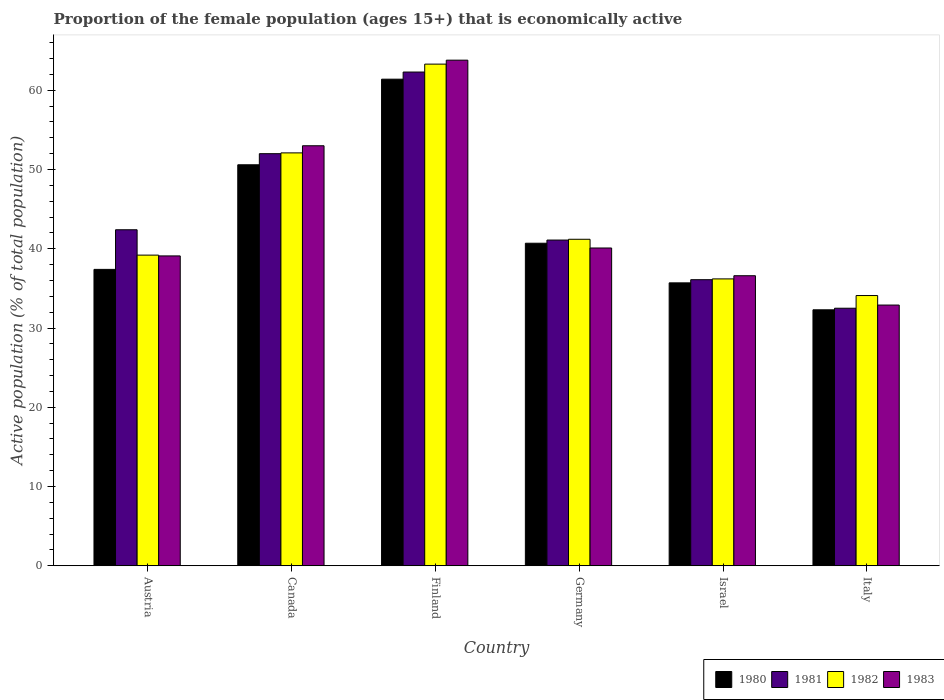How many different coloured bars are there?
Give a very brief answer. 4. How many bars are there on the 5th tick from the right?
Your answer should be very brief. 4. What is the label of the 1st group of bars from the left?
Your answer should be very brief. Austria. In how many cases, is the number of bars for a given country not equal to the number of legend labels?
Your answer should be compact. 0. What is the proportion of the female population that is economically active in 1983 in Austria?
Keep it short and to the point. 39.1. Across all countries, what is the maximum proportion of the female population that is economically active in 1980?
Ensure brevity in your answer.  61.4. Across all countries, what is the minimum proportion of the female population that is economically active in 1981?
Offer a very short reply. 32.5. In which country was the proportion of the female population that is economically active in 1983 maximum?
Provide a short and direct response. Finland. In which country was the proportion of the female population that is economically active in 1980 minimum?
Give a very brief answer. Italy. What is the total proportion of the female population that is economically active in 1983 in the graph?
Make the answer very short. 265.5. What is the difference between the proportion of the female population that is economically active in 1980 in Canada and that in Germany?
Your response must be concise. 9.9. What is the difference between the proportion of the female population that is economically active in 1980 in Israel and the proportion of the female population that is economically active in 1982 in Austria?
Your answer should be very brief. -3.5. What is the average proportion of the female population that is economically active in 1983 per country?
Ensure brevity in your answer.  44.25. What is the difference between the proportion of the female population that is economically active of/in 1981 and proportion of the female population that is economically active of/in 1983 in Austria?
Ensure brevity in your answer.  3.3. In how many countries, is the proportion of the female population that is economically active in 1982 greater than 2 %?
Your answer should be compact. 6. What is the ratio of the proportion of the female population that is economically active in 1980 in Austria to that in Israel?
Give a very brief answer. 1.05. Is the proportion of the female population that is economically active in 1981 in Canada less than that in Germany?
Keep it short and to the point. No. Is the difference between the proportion of the female population that is economically active in 1981 in Austria and Israel greater than the difference between the proportion of the female population that is economically active in 1983 in Austria and Israel?
Keep it short and to the point. Yes. What is the difference between the highest and the second highest proportion of the female population that is economically active in 1983?
Provide a short and direct response. -12.9. What is the difference between the highest and the lowest proportion of the female population that is economically active in 1983?
Offer a terse response. 30.9. Is the sum of the proportion of the female population that is economically active in 1981 in Germany and Italy greater than the maximum proportion of the female population that is economically active in 1983 across all countries?
Keep it short and to the point. Yes. Is it the case that in every country, the sum of the proportion of the female population that is economically active in 1983 and proportion of the female population that is economically active in 1981 is greater than the sum of proportion of the female population that is economically active in 1982 and proportion of the female population that is economically active in 1980?
Give a very brief answer. No. What does the 4th bar from the left in Israel represents?
Your answer should be compact. 1983. Is it the case that in every country, the sum of the proportion of the female population that is economically active in 1981 and proportion of the female population that is economically active in 1983 is greater than the proportion of the female population that is economically active in 1982?
Your answer should be compact. Yes. How many bars are there?
Your answer should be compact. 24. Does the graph contain grids?
Your response must be concise. No. Where does the legend appear in the graph?
Offer a very short reply. Bottom right. What is the title of the graph?
Make the answer very short. Proportion of the female population (ages 15+) that is economically active. What is the label or title of the X-axis?
Make the answer very short. Country. What is the label or title of the Y-axis?
Give a very brief answer. Active population (% of total population). What is the Active population (% of total population) of 1980 in Austria?
Give a very brief answer. 37.4. What is the Active population (% of total population) of 1981 in Austria?
Provide a succinct answer. 42.4. What is the Active population (% of total population) of 1982 in Austria?
Make the answer very short. 39.2. What is the Active population (% of total population) in 1983 in Austria?
Ensure brevity in your answer.  39.1. What is the Active population (% of total population) of 1980 in Canada?
Provide a short and direct response. 50.6. What is the Active population (% of total population) of 1981 in Canada?
Offer a very short reply. 52. What is the Active population (% of total population) of 1982 in Canada?
Offer a terse response. 52.1. What is the Active population (% of total population) of 1983 in Canada?
Your answer should be compact. 53. What is the Active population (% of total population) of 1980 in Finland?
Keep it short and to the point. 61.4. What is the Active population (% of total population) in 1981 in Finland?
Make the answer very short. 62.3. What is the Active population (% of total population) of 1982 in Finland?
Provide a short and direct response. 63.3. What is the Active population (% of total population) of 1983 in Finland?
Make the answer very short. 63.8. What is the Active population (% of total population) in 1980 in Germany?
Ensure brevity in your answer.  40.7. What is the Active population (% of total population) in 1981 in Germany?
Your answer should be very brief. 41.1. What is the Active population (% of total population) in 1982 in Germany?
Provide a succinct answer. 41.2. What is the Active population (% of total population) in 1983 in Germany?
Provide a short and direct response. 40.1. What is the Active population (% of total population) in 1980 in Israel?
Make the answer very short. 35.7. What is the Active population (% of total population) in 1981 in Israel?
Make the answer very short. 36.1. What is the Active population (% of total population) in 1982 in Israel?
Make the answer very short. 36.2. What is the Active population (% of total population) of 1983 in Israel?
Offer a very short reply. 36.6. What is the Active population (% of total population) of 1980 in Italy?
Provide a succinct answer. 32.3. What is the Active population (% of total population) of 1981 in Italy?
Offer a terse response. 32.5. What is the Active population (% of total population) of 1982 in Italy?
Keep it short and to the point. 34.1. What is the Active population (% of total population) of 1983 in Italy?
Make the answer very short. 32.9. Across all countries, what is the maximum Active population (% of total population) in 1980?
Provide a short and direct response. 61.4. Across all countries, what is the maximum Active population (% of total population) of 1981?
Offer a very short reply. 62.3. Across all countries, what is the maximum Active population (% of total population) in 1982?
Provide a succinct answer. 63.3. Across all countries, what is the maximum Active population (% of total population) of 1983?
Your answer should be compact. 63.8. Across all countries, what is the minimum Active population (% of total population) of 1980?
Keep it short and to the point. 32.3. Across all countries, what is the minimum Active population (% of total population) of 1981?
Your response must be concise. 32.5. Across all countries, what is the minimum Active population (% of total population) in 1982?
Give a very brief answer. 34.1. Across all countries, what is the minimum Active population (% of total population) in 1983?
Your answer should be very brief. 32.9. What is the total Active population (% of total population) of 1980 in the graph?
Provide a short and direct response. 258.1. What is the total Active population (% of total population) in 1981 in the graph?
Your answer should be compact. 266.4. What is the total Active population (% of total population) of 1982 in the graph?
Your answer should be compact. 266.1. What is the total Active population (% of total population) in 1983 in the graph?
Offer a terse response. 265.5. What is the difference between the Active population (% of total population) in 1980 in Austria and that in Canada?
Your answer should be very brief. -13.2. What is the difference between the Active population (% of total population) of 1981 in Austria and that in Canada?
Keep it short and to the point. -9.6. What is the difference between the Active population (% of total population) in 1982 in Austria and that in Canada?
Give a very brief answer. -12.9. What is the difference between the Active population (% of total population) of 1983 in Austria and that in Canada?
Keep it short and to the point. -13.9. What is the difference between the Active population (% of total population) of 1981 in Austria and that in Finland?
Make the answer very short. -19.9. What is the difference between the Active population (% of total population) of 1982 in Austria and that in Finland?
Give a very brief answer. -24.1. What is the difference between the Active population (% of total population) of 1983 in Austria and that in Finland?
Provide a short and direct response. -24.7. What is the difference between the Active population (% of total population) in 1982 in Austria and that in Germany?
Your response must be concise. -2. What is the difference between the Active population (% of total population) in 1980 in Austria and that in Israel?
Give a very brief answer. 1.7. What is the difference between the Active population (% of total population) of 1982 in Austria and that in Israel?
Your response must be concise. 3. What is the difference between the Active population (% of total population) in 1983 in Austria and that in Israel?
Provide a short and direct response. 2.5. What is the difference between the Active population (% of total population) of 1980 in Austria and that in Italy?
Offer a very short reply. 5.1. What is the difference between the Active population (% of total population) in 1981 in Austria and that in Italy?
Provide a short and direct response. 9.9. What is the difference between the Active population (% of total population) in 1981 in Canada and that in Germany?
Give a very brief answer. 10.9. What is the difference between the Active population (% of total population) of 1982 in Canada and that in Germany?
Your answer should be very brief. 10.9. What is the difference between the Active population (% of total population) in 1980 in Canada and that in Israel?
Ensure brevity in your answer.  14.9. What is the difference between the Active population (% of total population) in 1983 in Canada and that in Italy?
Offer a very short reply. 20.1. What is the difference between the Active population (% of total population) of 1980 in Finland and that in Germany?
Your answer should be compact. 20.7. What is the difference between the Active population (% of total population) of 1981 in Finland and that in Germany?
Offer a terse response. 21.2. What is the difference between the Active population (% of total population) of 1982 in Finland and that in Germany?
Keep it short and to the point. 22.1. What is the difference between the Active population (% of total population) in 1983 in Finland and that in Germany?
Your answer should be compact. 23.7. What is the difference between the Active population (% of total population) in 1980 in Finland and that in Israel?
Your answer should be very brief. 25.7. What is the difference between the Active population (% of total population) in 1981 in Finland and that in Israel?
Offer a very short reply. 26.2. What is the difference between the Active population (% of total population) in 1982 in Finland and that in Israel?
Your answer should be very brief. 27.1. What is the difference between the Active population (% of total population) of 1983 in Finland and that in Israel?
Provide a succinct answer. 27.2. What is the difference between the Active population (% of total population) of 1980 in Finland and that in Italy?
Offer a very short reply. 29.1. What is the difference between the Active population (% of total population) in 1981 in Finland and that in Italy?
Make the answer very short. 29.8. What is the difference between the Active population (% of total population) of 1982 in Finland and that in Italy?
Your answer should be very brief. 29.2. What is the difference between the Active population (% of total population) of 1983 in Finland and that in Italy?
Keep it short and to the point. 30.9. What is the difference between the Active population (% of total population) of 1982 in Germany and that in Israel?
Provide a short and direct response. 5. What is the difference between the Active population (% of total population) of 1983 in Germany and that in Israel?
Your answer should be compact. 3.5. What is the difference between the Active population (% of total population) of 1981 in Germany and that in Italy?
Ensure brevity in your answer.  8.6. What is the difference between the Active population (% of total population) in 1982 in Germany and that in Italy?
Offer a terse response. 7.1. What is the difference between the Active population (% of total population) in 1980 in Israel and that in Italy?
Your answer should be compact. 3.4. What is the difference between the Active population (% of total population) in 1980 in Austria and the Active population (% of total population) in 1981 in Canada?
Make the answer very short. -14.6. What is the difference between the Active population (% of total population) in 1980 in Austria and the Active population (% of total population) in 1982 in Canada?
Provide a short and direct response. -14.7. What is the difference between the Active population (% of total population) in 1980 in Austria and the Active population (% of total population) in 1983 in Canada?
Your answer should be compact. -15.6. What is the difference between the Active population (% of total population) in 1981 in Austria and the Active population (% of total population) in 1982 in Canada?
Your answer should be compact. -9.7. What is the difference between the Active population (% of total population) of 1981 in Austria and the Active population (% of total population) of 1983 in Canada?
Give a very brief answer. -10.6. What is the difference between the Active population (% of total population) in 1980 in Austria and the Active population (% of total population) in 1981 in Finland?
Make the answer very short. -24.9. What is the difference between the Active population (% of total population) of 1980 in Austria and the Active population (% of total population) of 1982 in Finland?
Offer a very short reply. -25.9. What is the difference between the Active population (% of total population) in 1980 in Austria and the Active population (% of total population) in 1983 in Finland?
Provide a succinct answer. -26.4. What is the difference between the Active population (% of total population) in 1981 in Austria and the Active population (% of total population) in 1982 in Finland?
Provide a short and direct response. -20.9. What is the difference between the Active population (% of total population) in 1981 in Austria and the Active population (% of total population) in 1983 in Finland?
Give a very brief answer. -21.4. What is the difference between the Active population (% of total population) of 1982 in Austria and the Active population (% of total population) of 1983 in Finland?
Give a very brief answer. -24.6. What is the difference between the Active population (% of total population) in 1980 in Austria and the Active population (% of total population) in 1981 in Germany?
Ensure brevity in your answer.  -3.7. What is the difference between the Active population (% of total population) in 1980 in Austria and the Active population (% of total population) in 1983 in Germany?
Provide a short and direct response. -2.7. What is the difference between the Active population (% of total population) of 1981 in Austria and the Active population (% of total population) of 1982 in Germany?
Keep it short and to the point. 1.2. What is the difference between the Active population (% of total population) in 1981 in Austria and the Active population (% of total population) in 1983 in Israel?
Offer a very short reply. 5.8. What is the difference between the Active population (% of total population) in 1982 in Austria and the Active population (% of total population) in 1983 in Israel?
Offer a very short reply. 2.6. What is the difference between the Active population (% of total population) of 1982 in Austria and the Active population (% of total population) of 1983 in Italy?
Your response must be concise. 6.3. What is the difference between the Active population (% of total population) of 1980 in Canada and the Active population (% of total population) of 1981 in Finland?
Your answer should be compact. -11.7. What is the difference between the Active population (% of total population) in 1981 in Canada and the Active population (% of total population) in 1983 in Finland?
Offer a very short reply. -11.8. What is the difference between the Active population (% of total population) of 1980 in Canada and the Active population (% of total population) of 1981 in Germany?
Provide a short and direct response. 9.5. What is the difference between the Active population (% of total population) of 1981 in Canada and the Active population (% of total population) of 1982 in Germany?
Ensure brevity in your answer.  10.8. What is the difference between the Active population (% of total population) in 1981 in Canada and the Active population (% of total population) in 1983 in Germany?
Your answer should be compact. 11.9. What is the difference between the Active population (% of total population) in 1982 in Canada and the Active population (% of total population) in 1983 in Germany?
Offer a terse response. 12. What is the difference between the Active population (% of total population) of 1980 in Canada and the Active population (% of total population) of 1982 in Israel?
Give a very brief answer. 14.4. What is the difference between the Active population (% of total population) of 1981 in Canada and the Active population (% of total population) of 1983 in Israel?
Offer a terse response. 15.4. What is the difference between the Active population (% of total population) in 1982 in Canada and the Active population (% of total population) in 1983 in Israel?
Keep it short and to the point. 15.5. What is the difference between the Active population (% of total population) of 1980 in Canada and the Active population (% of total population) of 1981 in Italy?
Provide a short and direct response. 18.1. What is the difference between the Active population (% of total population) of 1980 in Canada and the Active population (% of total population) of 1982 in Italy?
Provide a short and direct response. 16.5. What is the difference between the Active population (% of total population) of 1980 in Canada and the Active population (% of total population) of 1983 in Italy?
Offer a terse response. 17.7. What is the difference between the Active population (% of total population) of 1980 in Finland and the Active population (% of total population) of 1981 in Germany?
Ensure brevity in your answer.  20.3. What is the difference between the Active population (% of total population) of 1980 in Finland and the Active population (% of total population) of 1982 in Germany?
Keep it short and to the point. 20.2. What is the difference between the Active population (% of total population) in 1980 in Finland and the Active population (% of total population) in 1983 in Germany?
Offer a terse response. 21.3. What is the difference between the Active population (% of total population) of 1981 in Finland and the Active population (% of total population) of 1982 in Germany?
Give a very brief answer. 21.1. What is the difference between the Active population (% of total population) in 1981 in Finland and the Active population (% of total population) in 1983 in Germany?
Your response must be concise. 22.2. What is the difference between the Active population (% of total population) of 1982 in Finland and the Active population (% of total population) of 1983 in Germany?
Offer a terse response. 23.2. What is the difference between the Active population (% of total population) in 1980 in Finland and the Active population (% of total population) in 1981 in Israel?
Provide a short and direct response. 25.3. What is the difference between the Active population (% of total population) in 1980 in Finland and the Active population (% of total population) in 1982 in Israel?
Your answer should be compact. 25.2. What is the difference between the Active population (% of total population) in 1980 in Finland and the Active population (% of total population) in 1983 in Israel?
Provide a succinct answer. 24.8. What is the difference between the Active population (% of total population) in 1981 in Finland and the Active population (% of total population) in 1982 in Israel?
Your answer should be compact. 26.1. What is the difference between the Active population (% of total population) of 1981 in Finland and the Active population (% of total population) of 1983 in Israel?
Your answer should be compact. 25.7. What is the difference between the Active population (% of total population) of 1982 in Finland and the Active population (% of total population) of 1983 in Israel?
Provide a succinct answer. 26.7. What is the difference between the Active population (% of total population) of 1980 in Finland and the Active population (% of total population) of 1981 in Italy?
Offer a terse response. 28.9. What is the difference between the Active population (% of total population) in 1980 in Finland and the Active population (% of total population) in 1982 in Italy?
Make the answer very short. 27.3. What is the difference between the Active population (% of total population) of 1981 in Finland and the Active population (% of total population) of 1982 in Italy?
Your response must be concise. 28.2. What is the difference between the Active population (% of total population) in 1981 in Finland and the Active population (% of total population) in 1983 in Italy?
Your answer should be very brief. 29.4. What is the difference between the Active population (% of total population) in 1982 in Finland and the Active population (% of total population) in 1983 in Italy?
Your response must be concise. 30.4. What is the difference between the Active population (% of total population) in 1980 in Germany and the Active population (% of total population) in 1983 in Israel?
Give a very brief answer. 4.1. What is the difference between the Active population (% of total population) of 1981 in Germany and the Active population (% of total population) of 1982 in Israel?
Provide a short and direct response. 4.9. What is the difference between the Active population (% of total population) in 1980 in Germany and the Active population (% of total population) in 1982 in Italy?
Offer a very short reply. 6.6. What is the difference between the Active population (% of total population) of 1980 in Israel and the Active population (% of total population) of 1981 in Italy?
Your response must be concise. 3.2. What is the difference between the Active population (% of total population) of 1980 in Israel and the Active population (% of total population) of 1982 in Italy?
Make the answer very short. 1.6. What is the difference between the Active population (% of total population) of 1980 in Israel and the Active population (% of total population) of 1983 in Italy?
Ensure brevity in your answer.  2.8. What is the difference between the Active population (% of total population) in 1981 in Israel and the Active population (% of total population) in 1982 in Italy?
Make the answer very short. 2. What is the difference between the Active population (% of total population) in 1981 in Israel and the Active population (% of total population) in 1983 in Italy?
Give a very brief answer. 3.2. What is the average Active population (% of total population) in 1980 per country?
Give a very brief answer. 43.02. What is the average Active population (% of total population) in 1981 per country?
Provide a short and direct response. 44.4. What is the average Active population (% of total population) of 1982 per country?
Provide a succinct answer. 44.35. What is the average Active population (% of total population) of 1983 per country?
Your answer should be very brief. 44.25. What is the difference between the Active population (% of total population) of 1980 and Active population (% of total population) of 1981 in Austria?
Make the answer very short. -5. What is the difference between the Active population (% of total population) in 1980 and Active population (% of total population) in 1983 in Austria?
Provide a succinct answer. -1.7. What is the difference between the Active population (% of total population) in 1981 and Active population (% of total population) in 1982 in Austria?
Ensure brevity in your answer.  3.2. What is the difference between the Active population (% of total population) of 1981 and Active population (% of total population) of 1983 in Austria?
Your answer should be compact. 3.3. What is the difference between the Active population (% of total population) in 1982 and Active population (% of total population) in 1983 in Austria?
Keep it short and to the point. 0.1. What is the difference between the Active population (% of total population) of 1980 and Active population (% of total population) of 1981 in Canada?
Offer a very short reply. -1.4. What is the difference between the Active population (% of total population) in 1980 and Active population (% of total population) in 1983 in Canada?
Keep it short and to the point. -2.4. What is the difference between the Active population (% of total population) in 1981 and Active population (% of total population) in 1983 in Canada?
Provide a short and direct response. -1. What is the difference between the Active population (% of total population) in 1982 and Active population (% of total population) in 1983 in Canada?
Your answer should be compact. -0.9. What is the difference between the Active population (% of total population) in 1980 and Active population (% of total population) in 1981 in Finland?
Make the answer very short. -0.9. What is the difference between the Active population (% of total population) of 1980 and Active population (% of total population) of 1982 in Germany?
Ensure brevity in your answer.  -0.5. What is the difference between the Active population (% of total population) in 1981 and Active population (% of total population) in 1982 in Germany?
Provide a short and direct response. -0.1. What is the difference between the Active population (% of total population) in 1980 and Active population (% of total population) in 1981 in Israel?
Ensure brevity in your answer.  -0.4. What is the difference between the Active population (% of total population) in 1982 and Active population (% of total population) in 1983 in Israel?
Your answer should be very brief. -0.4. What is the difference between the Active population (% of total population) in 1980 and Active population (% of total population) in 1981 in Italy?
Make the answer very short. -0.2. What is the difference between the Active population (% of total population) of 1980 and Active population (% of total population) of 1982 in Italy?
Ensure brevity in your answer.  -1.8. What is the difference between the Active population (% of total population) in 1981 and Active population (% of total population) in 1983 in Italy?
Offer a terse response. -0.4. What is the difference between the Active population (% of total population) in 1982 and Active population (% of total population) in 1983 in Italy?
Make the answer very short. 1.2. What is the ratio of the Active population (% of total population) of 1980 in Austria to that in Canada?
Your response must be concise. 0.74. What is the ratio of the Active population (% of total population) of 1981 in Austria to that in Canada?
Provide a short and direct response. 0.82. What is the ratio of the Active population (% of total population) of 1982 in Austria to that in Canada?
Provide a succinct answer. 0.75. What is the ratio of the Active population (% of total population) in 1983 in Austria to that in Canada?
Keep it short and to the point. 0.74. What is the ratio of the Active population (% of total population) of 1980 in Austria to that in Finland?
Provide a succinct answer. 0.61. What is the ratio of the Active population (% of total population) in 1981 in Austria to that in Finland?
Give a very brief answer. 0.68. What is the ratio of the Active population (% of total population) of 1982 in Austria to that in Finland?
Your answer should be compact. 0.62. What is the ratio of the Active population (% of total population) of 1983 in Austria to that in Finland?
Offer a terse response. 0.61. What is the ratio of the Active population (% of total population) in 1980 in Austria to that in Germany?
Your response must be concise. 0.92. What is the ratio of the Active population (% of total population) in 1981 in Austria to that in Germany?
Provide a short and direct response. 1.03. What is the ratio of the Active population (% of total population) in 1982 in Austria to that in Germany?
Provide a short and direct response. 0.95. What is the ratio of the Active population (% of total population) of 1983 in Austria to that in Germany?
Make the answer very short. 0.98. What is the ratio of the Active population (% of total population) of 1980 in Austria to that in Israel?
Your answer should be compact. 1.05. What is the ratio of the Active population (% of total population) of 1981 in Austria to that in Israel?
Give a very brief answer. 1.17. What is the ratio of the Active population (% of total population) in 1982 in Austria to that in Israel?
Offer a very short reply. 1.08. What is the ratio of the Active population (% of total population) in 1983 in Austria to that in Israel?
Ensure brevity in your answer.  1.07. What is the ratio of the Active population (% of total population) of 1980 in Austria to that in Italy?
Give a very brief answer. 1.16. What is the ratio of the Active population (% of total population) in 1981 in Austria to that in Italy?
Provide a succinct answer. 1.3. What is the ratio of the Active population (% of total population) in 1982 in Austria to that in Italy?
Make the answer very short. 1.15. What is the ratio of the Active population (% of total population) of 1983 in Austria to that in Italy?
Your answer should be very brief. 1.19. What is the ratio of the Active population (% of total population) of 1980 in Canada to that in Finland?
Your answer should be very brief. 0.82. What is the ratio of the Active population (% of total population) of 1981 in Canada to that in Finland?
Provide a succinct answer. 0.83. What is the ratio of the Active population (% of total population) of 1982 in Canada to that in Finland?
Provide a short and direct response. 0.82. What is the ratio of the Active population (% of total population) of 1983 in Canada to that in Finland?
Provide a succinct answer. 0.83. What is the ratio of the Active population (% of total population) of 1980 in Canada to that in Germany?
Keep it short and to the point. 1.24. What is the ratio of the Active population (% of total population) of 1981 in Canada to that in Germany?
Give a very brief answer. 1.27. What is the ratio of the Active population (% of total population) of 1982 in Canada to that in Germany?
Your answer should be compact. 1.26. What is the ratio of the Active population (% of total population) of 1983 in Canada to that in Germany?
Keep it short and to the point. 1.32. What is the ratio of the Active population (% of total population) in 1980 in Canada to that in Israel?
Offer a terse response. 1.42. What is the ratio of the Active population (% of total population) in 1981 in Canada to that in Israel?
Provide a short and direct response. 1.44. What is the ratio of the Active population (% of total population) in 1982 in Canada to that in Israel?
Ensure brevity in your answer.  1.44. What is the ratio of the Active population (% of total population) of 1983 in Canada to that in Israel?
Keep it short and to the point. 1.45. What is the ratio of the Active population (% of total population) of 1980 in Canada to that in Italy?
Your response must be concise. 1.57. What is the ratio of the Active population (% of total population) of 1982 in Canada to that in Italy?
Provide a short and direct response. 1.53. What is the ratio of the Active population (% of total population) in 1983 in Canada to that in Italy?
Offer a very short reply. 1.61. What is the ratio of the Active population (% of total population) of 1980 in Finland to that in Germany?
Keep it short and to the point. 1.51. What is the ratio of the Active population (% of total population) in 1981 in Finland to that in Germany?
Offer a terse response. 1.52. What is the ratio of the Active population (% of total population) in 1982 in Finland to that in Germany?
Your response must be concise. 1.54. What is the ratio of the Active population (% of total population) in 1983 in Finland to that in Germany?
Give a very brief answer. 1.59. What is the ratio of the Active population (% of total population) of 1980 in Finland to that in Israel?
Your response must be concise. 1.72. What is the ratio of the Active population (% of total population) of 1981 in Finland to that in Israel?
Offer a very short reply. 1.73. What is the ratio of the Active population (% of total population) in 1982 in Finland to that in Israel?
Your response must be concise. 1.75. What is the ratio of the Active population (% of total population) in 1983 in Finland to that in Israel?
Give a very brief answer. 1.74. What is the ratio of the Active population (% of total population) in 1980 in Finland to that in Italy?
Give a very brief answer. 1.9. What is the ratio of the Active population (% of total population) in 1981 in Finland to that in Italy?
Offer a very short reply. 1.92. What is the ratio of the Active population (% of total population) in 1982 in Finland to that in Italy?
Your response must be concise. 1.86. What is the ratio of the Active population (% of total population) of 1983 in Finland to that in Italy?
Offer a terse response. 1.94. What is the ratio of the Active population (% of total population) in 1980 in Germany to that in Israel?
Ensure brevity in your answer.  1.14. What is the ratio of the Active population (% of total population) of 1981 in Germany to that in Israel?
Offer a very short reply. 1.14. What is the ratio of the Active population (% of total population) in 1982 in Germany to that in Israel?
Keep it short and to the point. 1.14. What is the ratio of the Active population (% of total population) of 1983 in Germany to that in Israel?
Your response must be concise. 1.1. What is the ratio of the Active population (% of total population) of 1980 in Germany to that in Italy?
Offer a very short reply. 1.26. What is the ratio of the Active population (% of total population) in 1981 in Germany to that in Italy?
Your response must be concise. 1.26. What is the ratio of the Active population (% of total population) in 1982 in Germany to that in Italy?
Provide a succinct answer. 1.21. What is the ratio of the Active population (% of total population) of 1983 in Germany to that in Italy?
Your response must be concise. 1.22. What is the ratio of the Active population (% of total population) of 1980 in Israel to that in Italy?
Offer a terse response. 1.11. What is the ratio of the Active population (% of total population) of 1981 in Israel to that in Italy?
Give a very brief answer. 1.11. What is the ratio of the Active population (% of total population) in 1982 in Israel to that in Italy?
Provide a succinct answer. 1.06. What is the ratio of the Active population (% of total population) of 1983 in Israel to that in Italy?
Offer a terse response. 1.11. What is the difference between the highest and the second highest Active population (% of total population) in 1980?
Your answer should be compact. 10.8. What is the difference between the highest and the second highest Active population (% of total population) in 1983?
Offer a very short reply. 10.8. What is the difference between the highest and the lowest Active population (% of total population) of 1980?
Your answer should be very brief. 29.1. What is the difference between the highest and the lowest Active population (% of total population) in 1981?
Provide a short and direct response. 29.8. What is the difference between the highest and the lowest Active population (% of total population) of 1982?
Provide a succinct answer. 29.2. What is the difference between the highest and the lowest Active population (% of total population) of 1983?
Your answer should be compact. 30.9. 